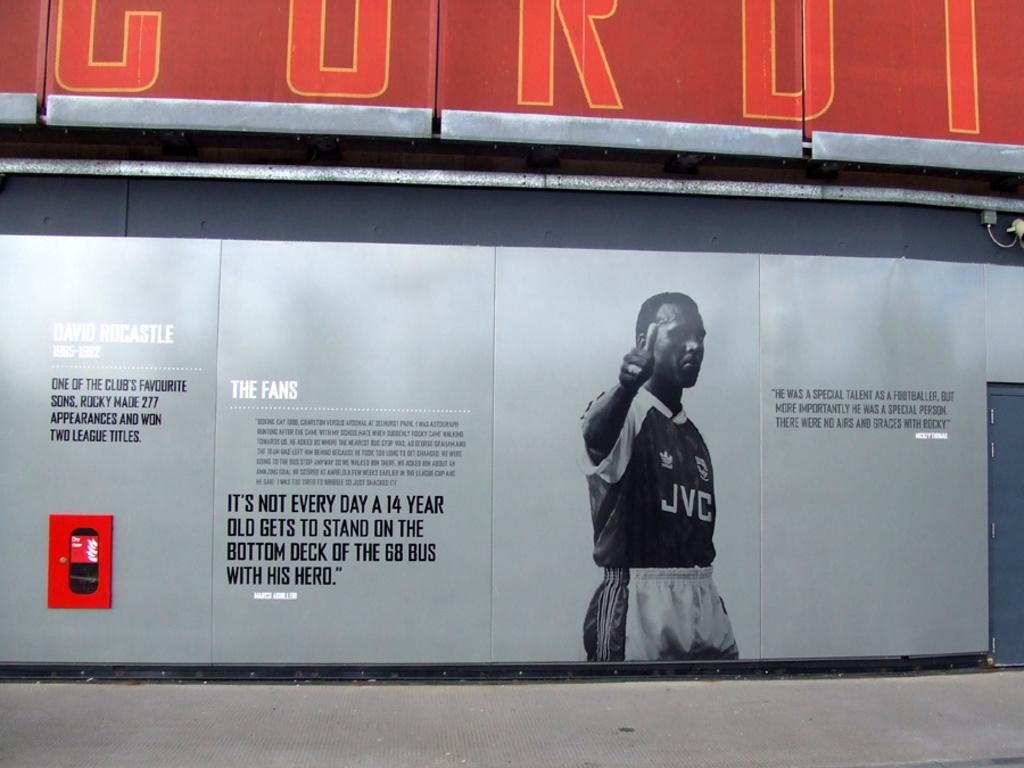<image>
Create a compact narrative representing the image presented. A poster shows a man in a JVC shirt next to an inspirational message, 